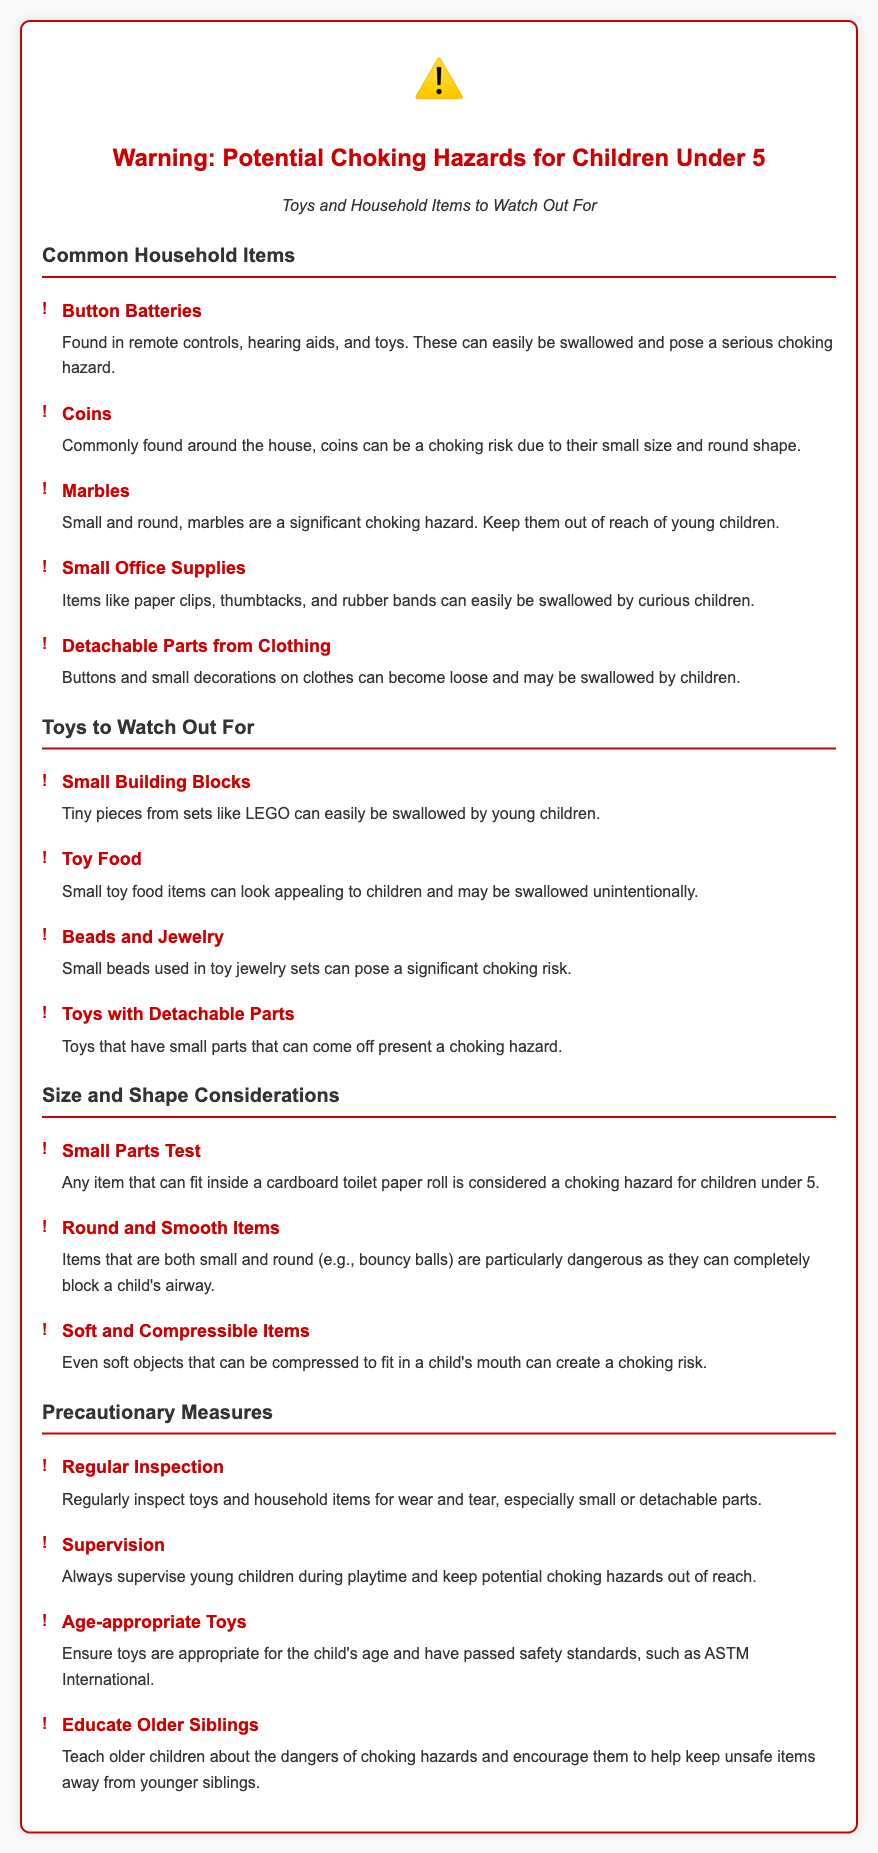What is the title of the warning label? The title of the document clearly states the purpose and main concern regarding choking hazards for young children.
Answer: Warning: Potential Choking Hazards for Children Under 5 What symbol is displayed at the top of the document? The document includes a warning icon to emphasize the seriousness of the choking hazard concern.
Answer: ⚠️ Which household item is specifically mentioned as found in remote controls? The list of common household items highlights specific examples that can pose choking hazards, including those found in everyday items like remote controls.
Answer: Button Batteries What should you regularly inspect for safety? The document advises caregivers to check specific types of items to prevent accidents.
Answer: Toys and household items What is the size reference for choking hazards? The document provides a specific measurement that indicates whether an item is a potential choking hazard for children under five.
Answer: Cardboard toilet paper roll What color is used for the headings in the document? The headings use a specific color to stand out and draw attention to important sections within the warning.
Answer: Red What type of items should be kept out of reach during playtime? The document gives clear guidance on supervision and access to certain small items that may be dangerous to young children.
Answer: Potential choking hazards What is the first precautionary measure listed? The document prioritizes precautionary actions to ensure children's safety against choking hazards, starting with a particular action.
Answer: Regular Inspection 